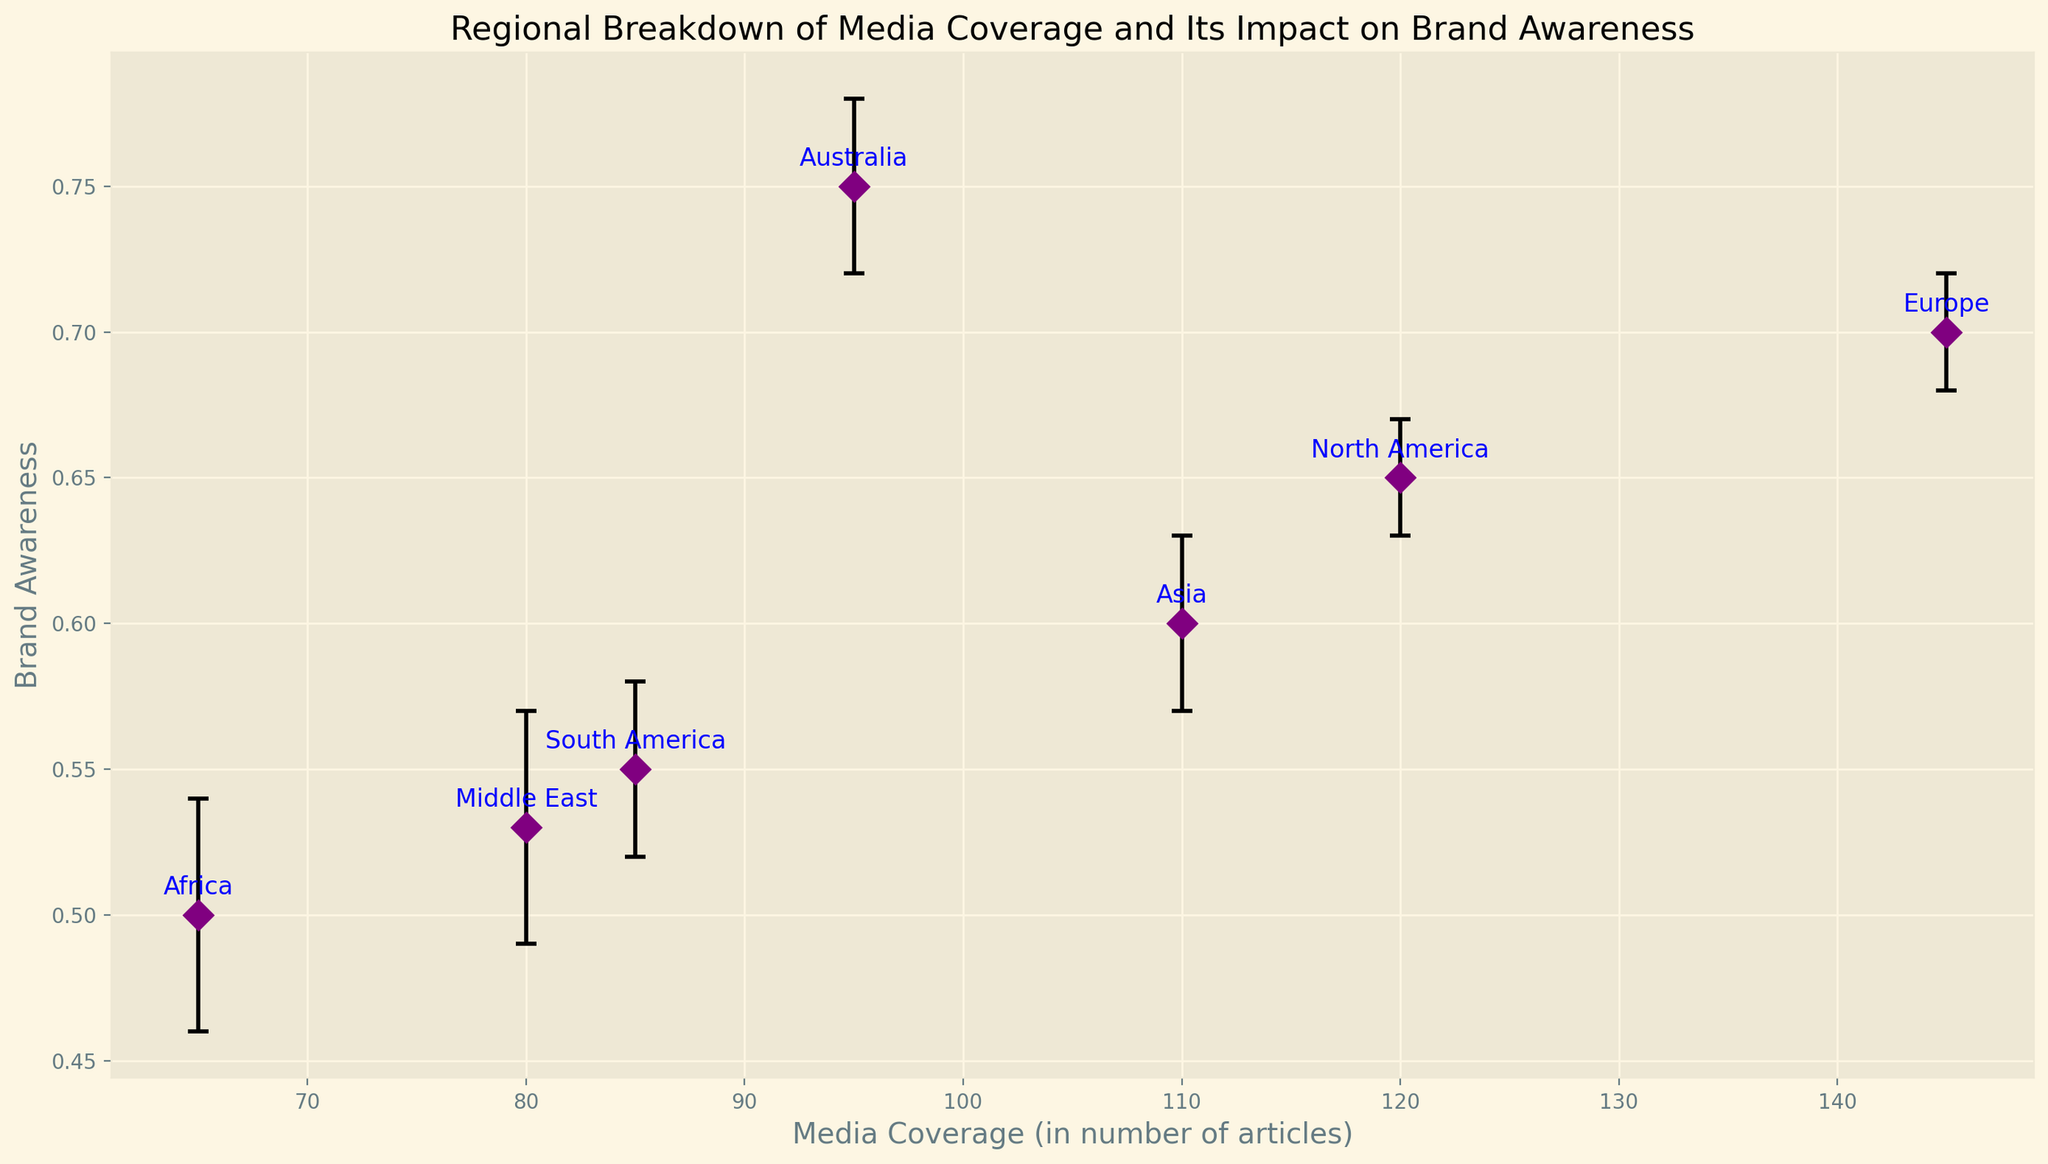What region has the highest media coverage? By looking at the x-axis, the region with the highest media coverage is the one with the furthest data point to the right. Here, that region is Europe with a media coverage of 145.
Answer: Europe Which region has the lowest brand awareness? By looking at the y-axis, the region with the data point closest to the bottom represents the lowest brand awareness. Here, that region is Africa with a brand awareness of 0.50.
Answer: Africa What is the confidence interval for brand awareness in Asia? By examining the error bars for the Asia data point, the lower bound of the interval is 0.57 and the upper bound is 0.63.
Answer: 0.57 to 0.63 How does brand awareness in Australia compare to that in South America? Australia's brand awareness (0.75) is significantly higher than that in South America (0.55). This can be seen by comparing the vertical positions of the data points.
Answer: Higher Which region has the smallest range of its confidence interval for brand awareness? This involves comparing the length of the error bars for all regions to find the shortest one. Here, Europe has the smallest range with bounds from 0.68 to 0.72, resulting in a range of 0.04.
Answer: Europe What is the average brand awareness for Europe and North America? The brand awareness for Europe is 0.70 and for North America is 0.65. The average is calculated as (0.70 + 0.65)/2 = 0.675.
Answer: 0.675 How many regions have brand awareness above 0.60? By reviewing each data point visually, regions above a brand awareness of 0.60 are North America (0.65), Europe (0.70), and Australia (0.75). Therefore, there are 3 regions.
Answer: 3 Which region has the broadest confidence interval for brand awareness? This requires finding the region with the largest interval. The Middle East has bounds from 0.49 to 0.57, resulting in a range of 0.08, which is the broadest among all regions.
Answer: Middle East What is the difference in media coverage between Europe and Asia? Europe has 145 and Asia has 110. The difference is calculated as 145 - 110 = 35.
Answer: 35 